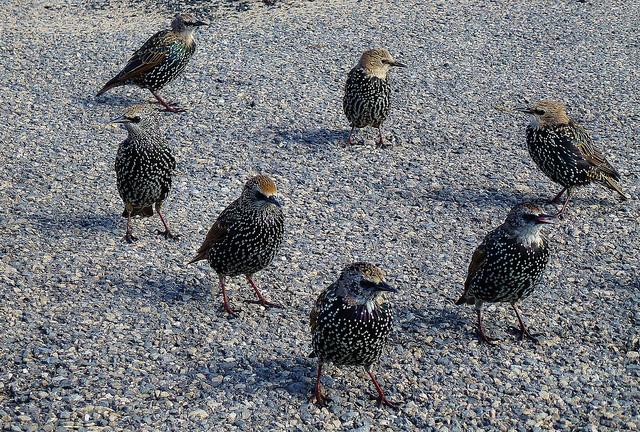How many birds are looking to the left?
Be succinct. 2. Are these birds in flight?
Concise answer only. No. Are these birds at the beach?
Be succinct. No. 